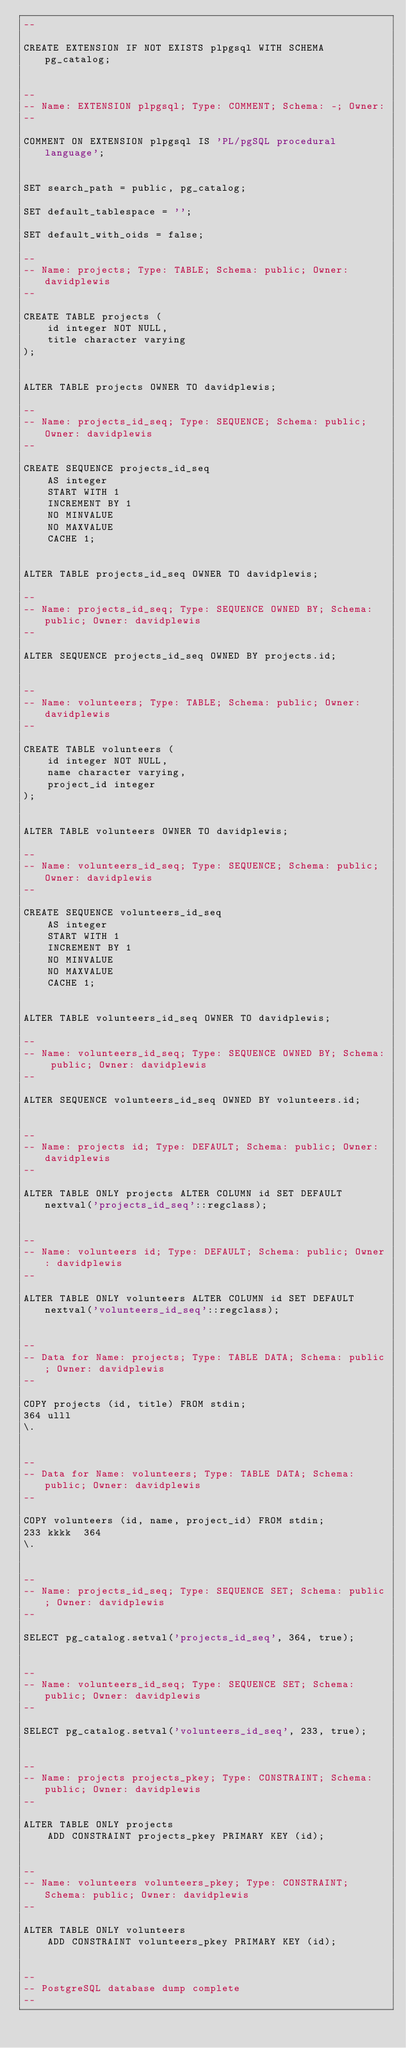<code> <loc_0><loc_0><loc_500><loc_500><_SQL_>--

CREATE EXTENSION IF NOT EXISTS plpgsql WITH SCHEMA pg_catalog;


--
-- Name: EXTENSION plpgsql; Type: COMMENT; Schema: -; Owner: 
--

COMMENT ON EXTENSION plpgsql IS 'PL/pgSQL procedural language';


SET search_path = public, pg_catalog;

SET default_tablespace = '';

SET default_with_oids = false;

--
-- Name: projects; Type: TABLE; Schema: public; Owner: davidplewis
--

CREATE TABLE projects (
    id integer NOT NULL,
    title character varying
);


ALTER TABLE projects OWNER TO davidplewis;

--
-- Name: projects_id_seq; Type: SEQUENCE; Schema: public; Owner: davidplewis
--

CREATE SEQUENCE projects_id_seq
    AS integer
    START WITH 1
    INCREMENT BY 1
    NO MINVALUE
    NO MAXVALUE
    CACHE 1;


ALTER TABLE projects_id_seq OWNER TO davidplewis;

--
-- Name: projects_id_seq; Type: SEQUENCE OWNED BY; Schema: public; Owner: davidplewis
--

ALTER SEQUENCE projects_id_seq OWNED BY projects.id;


--
-- Name: volunteers; Type: TABLE; Schema: public; Owner: davidplewis
--

CREATE TABLE volunteers (
    id integer NOT NULL,
    name character varying,
    project_id integer
);


ALTER TABLE volunteers OWNER TO davidplewis;

--
-- Name: volunteers_id_seq; Type: SEQUENCE; Schema: public; Owner: davidplewis
--

CREATE SEQUENCE volunteers_id_seq
    AS integer
    START WITH 1
    INCREMENT BY 1
    NO MINVALUE
    NO MAXVALUE
    CACHE 1;


ALTER TABLE volunteers_id_seq OWNER TO davidplewis;

--
-- Name: volunteers_id_seq; Type: SEQUENCE OWNED BY; Schema: public; Owner: davidplewis
--

ALTER SEQUENCE volunteers_id_seq OWNED BY volunteers.id;


--
-- Name: projects id; Type: DEFAULT; Schema: public; Owner: davidplewis
--

ALTER TABLE ONLY projects ALTER COLUMN id SET DEFAULT nextval('projects_id_seq'::regclass);


--
-- Name: volunteers id; Type: DEFAULT; Schema: public; Owner: davidplewis
--

ALTER TABLE ONLY volunteers ALTER COLUMN id SET DEFAULT nextval('volunteers_id_seq'::regclass);


--
-- Data for Name: projects; Type: TABLE DATA; Schema: public; Owner: davidplewis
--

COPY projects (id, title) FROM stdin;
364	ulll
\.


--
-- Data for Name: volunteers; Type: TABLE DATA; Schema: public; Owner: davidplewis
--

COPY volunteers (id, name, project_id) FROM stdin;
233	kkkk	364
\.


--
-- Name: projects_id_seq; Type: SEQUENCE SET; Schema: public; Owner: davidplewis
--

SELECT pg_catalog.setval('projects_id_seq', 364, true);


--
-- Name: volunteers_id_seq; Type: SEQUENCE SET; Schema: public; Owner: davidplewis
--

SELECT pg_catalog.setval('volunteers_id_seq', 233, true);


--
-- Name: projects projects_pkey; Type: CONSTRAINT; Schema: public; Owner: davidplewis
--

ALTER TABLE ONLY projects
    ADD CONSTRAINT projects_pkey PRIMARY KEY (id);


--
-- Name: volunteers volunteers_pkey; Type: CONSTRAINT; Schema: public; Owner: davidplewis
--

ALTER TABLE ONLY volunteers
    ADD CONSTRAINT volunteers_pkey PRIMARY KEY (id);


--
-- PostgreSQL database dump complete
--

</code> 